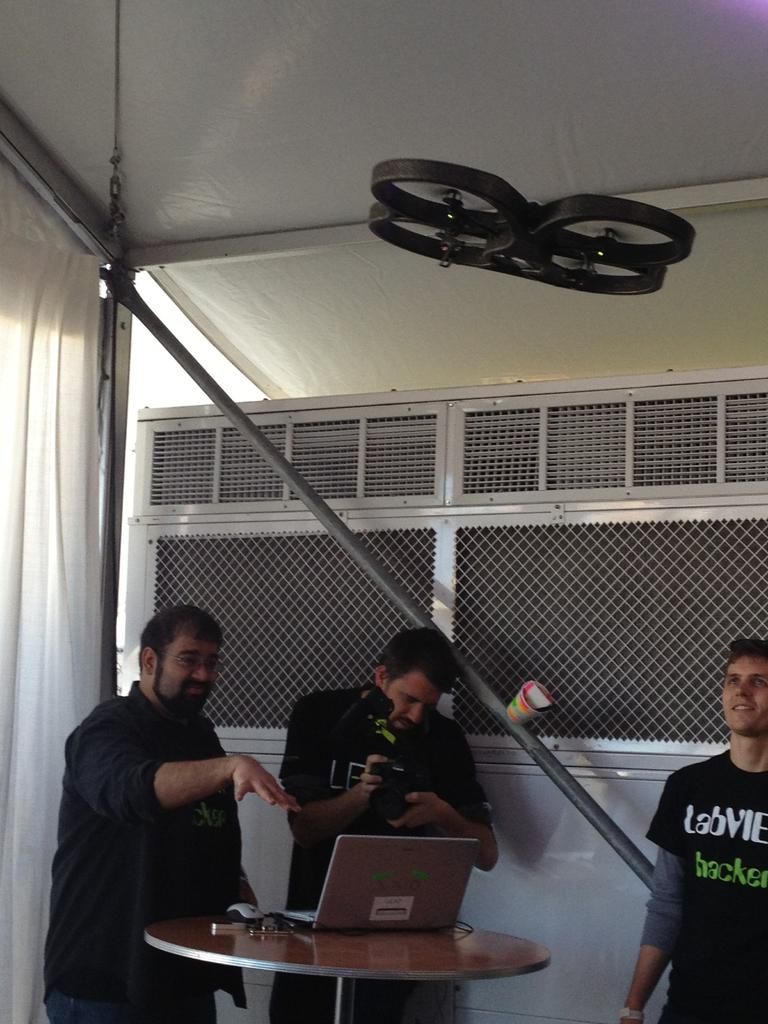How many people are in the image? There are three men in the image. What are the men doing in the image? The men are standing at a table. What object is on the table in the image? There is a laptop on the table. What type of material is visible in the image? There is a cloth visible in the image. What architectural feature can be seen in the image? There is a pole in the image. What type of horse can be seen eating oranges in the image? There is no horse or oranges present in the image. 